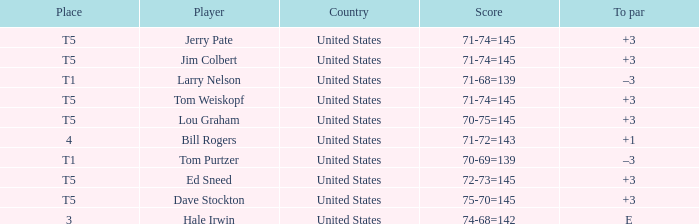What is the country of player ed sneed with a to par of +3? United States. 